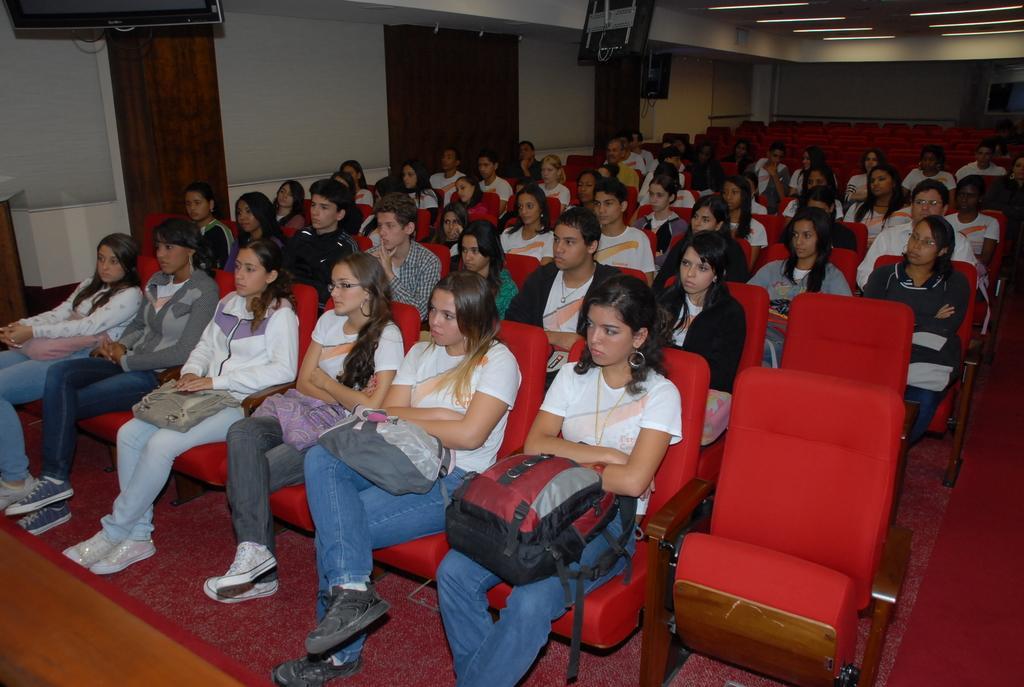How would you summarize this image in a sentence or two? In this image there is a group of persons sitting on a red color chairs in the middle of this image. There is a wall in the background. There are some display screens on the top of this image. 